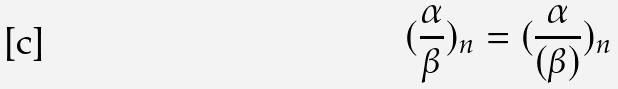Convert formula to latex. <formula><loc_0><loc_0><loc_500><loc_500>( \frac { \alpha } { \beta } ) _ { n } = ( \frac { \alpha } { ( \beta ) } ) _ { n }</formula> 